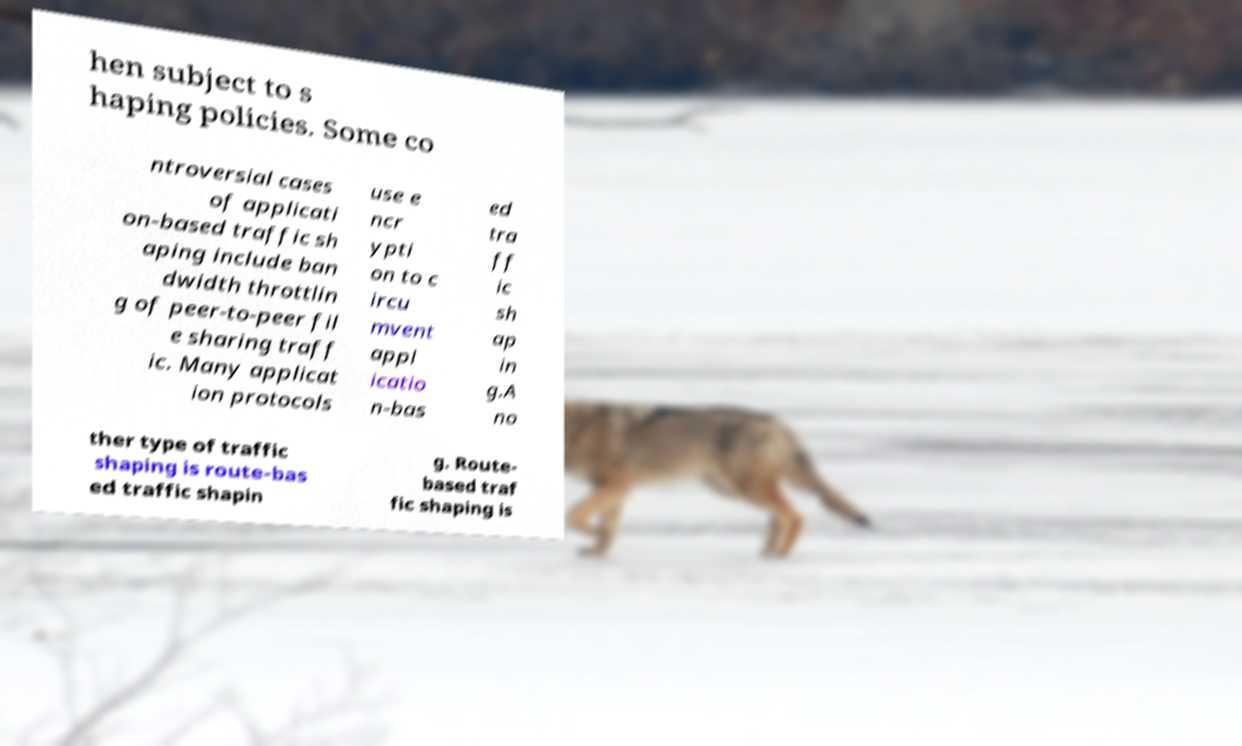There's text embedded in this image that I need extracted. Can you transcribe it verbatim? hen subject to s haping policies. Some co ntroversial cases of applicati on-based traffic sh aping include ban dwidth throttlin g of peer-to-peer fil e sharing traff ic. Many applicat ion protocols use e ncr ypti on to c ircu mvent appl icatio n-bas ed tra ff ic sh ap in g.A no ther type of traffic shaping is route-bas ed traffic shapin g. Route- based traf fic shaping is 